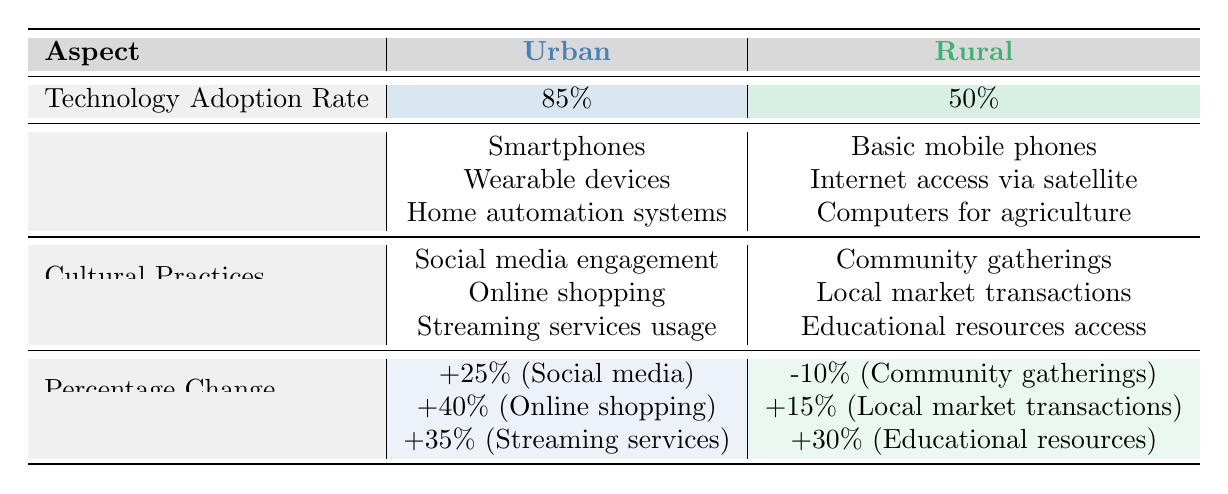What is the technology adoption rate in urban areas? The table indicates that the technology adoption rate in urban areas is 85%.
Answer: 85% What common technologies are used in rural areas? The table lists the common technologies in rural areas as Basic mobile phones, Internet access via satellite, and Computers for agriculture.
Answer: Basic mobile phones, Internet access via satellite, Computers for agriculture Is online shopping a cultural practice affected by technology adoption in urban areas? Yes, the table specifies online shopping as one of the cultural practices affected by technology adoption in urban areas.
Answer: Yes What is the percentage change in community gatherings in rural areas? According to the table, the percentage change in community gatherings in rural areas is -10%.
Answer: -10% Which area type shows a greater positive change in streaming services usage? The table shows that urban areas have a 35% increase, while rural areas do not have a listed change, hence urban areas show a greater positive change in streaming services usage.
Answer: Urban areas What is the difference in technology adoption rates between urban and rural areas? The table shows a technology adoption rate of 85% in urban areas and 50% in rural areas. Therefore, the difference is 85% - 50% = 35%.
Answer: 35% How many cultural practices are affected by technology adoption in urban areas? The table mentions three cultural practices affected by technology adoption in urban areas: Social media engagement, Online shopping, and Streaming services usage.
Answer: 3 Is the change in access to educational resources positive in rural areas? Yes, the table indicates that the percentage change in access to educational resources in rural areas is 30%, which is a positive change.
Answer: Yes What is the average percentage change in cultural practices for urban areas? The urban area has three changes: +25% (Social media), +40% (Online shopping), and +35% (Streaming services). The average is calculated as (25 + 40 + 35) / 3 = 100 / 3 = 33.33%.
Answer: 33.33% Which area has a higher adoption rate of technology and what is that rate? The table shows urban areas with a technology adoption rate of 85%, which is higher than the rural rate of 50%.
Answer: Urban areas, 85% 